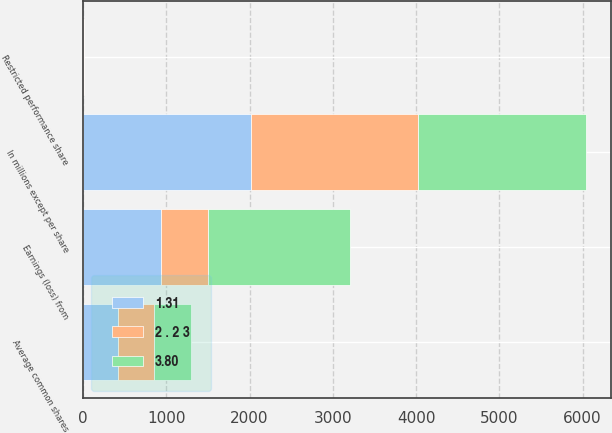Convert chart to OTSL. <chart><loc_0><loc_0><loc_500><loc_500><stacked_bar_chart><ecel><fcel>In millions except per share<fcel>Earnings (loss) from<fcel>Average common shares<fcel>Restricted performance share<nl><fcel>1.31<fcel>2015<fcel>938<fcel>420.6<fcel>3.2<nl><fcel>2 . 2 3<fcel>2014<fcel>568<fcel>432<fcel>4.2<nl><fcel>3.80<fcel>2013<fcel>1704<fcel>448.1<fcel>4.5<nl></chart> 